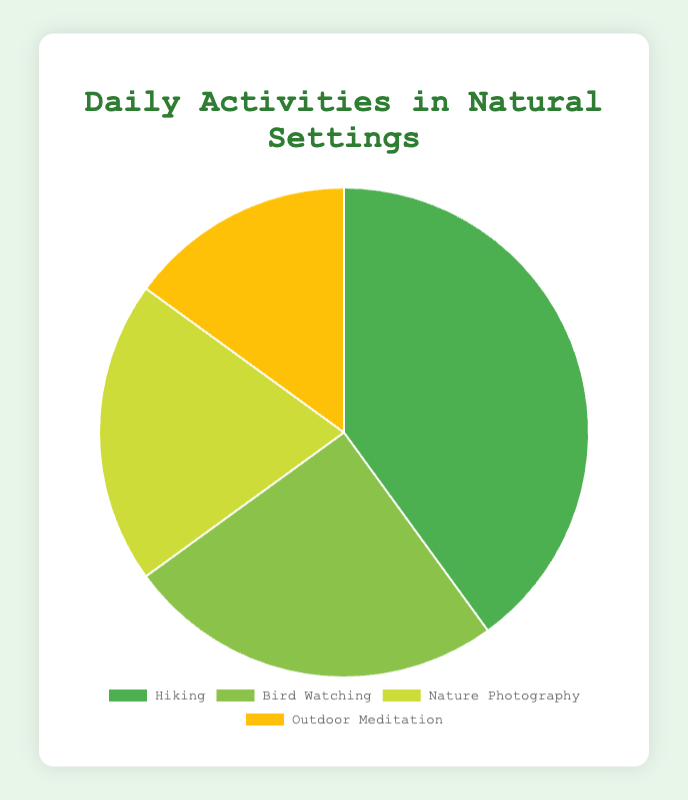What's the largest activity segment in the pie chart? The largest activity segment is the one with the highest percentage. In the chart, Hiking has the highest percentage at 40%
Answer: Hiking Which activity has the smallest portion in the pie chart? The smallest portion is indicated by the smallest percentage. Outdoor Meditation has the smallest portion with 15%
Answer: Outdoor Meditation What is the combined percentage of Bird Watching and Nature Photography? Add the percentages of Bird Watching (25%) and Nature Photography (20%). 25% + 20% = 45%
Answer: 45% Is the percentage of Hiking greater than the combined percentage of Outdoor Meditation and Nature Photography? Hiking has 40%. The combined percentage of Outdoor Meditation (15%) and Nature Photography (20%) is 15% + 20% = 35%. 40% > 35%
Answer: Yes What is the difference in percentage between the largest and smallest activity segments? The largest segment is Hiking with 40%, and the smallest is Outdoor Meditation with 15%. The difference is 40% - 15% = 25%
Answer: 25% Which two activities together make up half of the total percentages in the pie chart? Two activities that together make up around 50%. Hiking is 40% and Bird Watching is 25%. 40% + 25% = 65%, which is more than half. However, Nature Photography (20%) and Outdoor Meditation (15%) together make 35%, which is less. Hiking (40%) and Nature Photography (20%) together make 60%, which is above half. Thus, there is no exact combination making up exactly 50%, but Hiking and Bird Watching together are closest with 40% + 25% = 65%
Answer: Hiking and Bird Watching What percentage more is Hiking than Nature Photography? Calculate the difference in percentages between Hiking (40%) and Nature Photography (20%). 40% - 20% = 20%
Answer: 20% How many activities have a percentage greater than 20%? Count the activities with percentages over 20%. Hiking (40%) and Bird Watching (25%) both have percentages over 20%
Answer: 2 What's the average percentage of all activities? Sum the percentages of all activities and divide by the number of activities. (40% + 25% + 20% + 15%) / 4 = 100% / 4 = 25%
Answer: 25% 